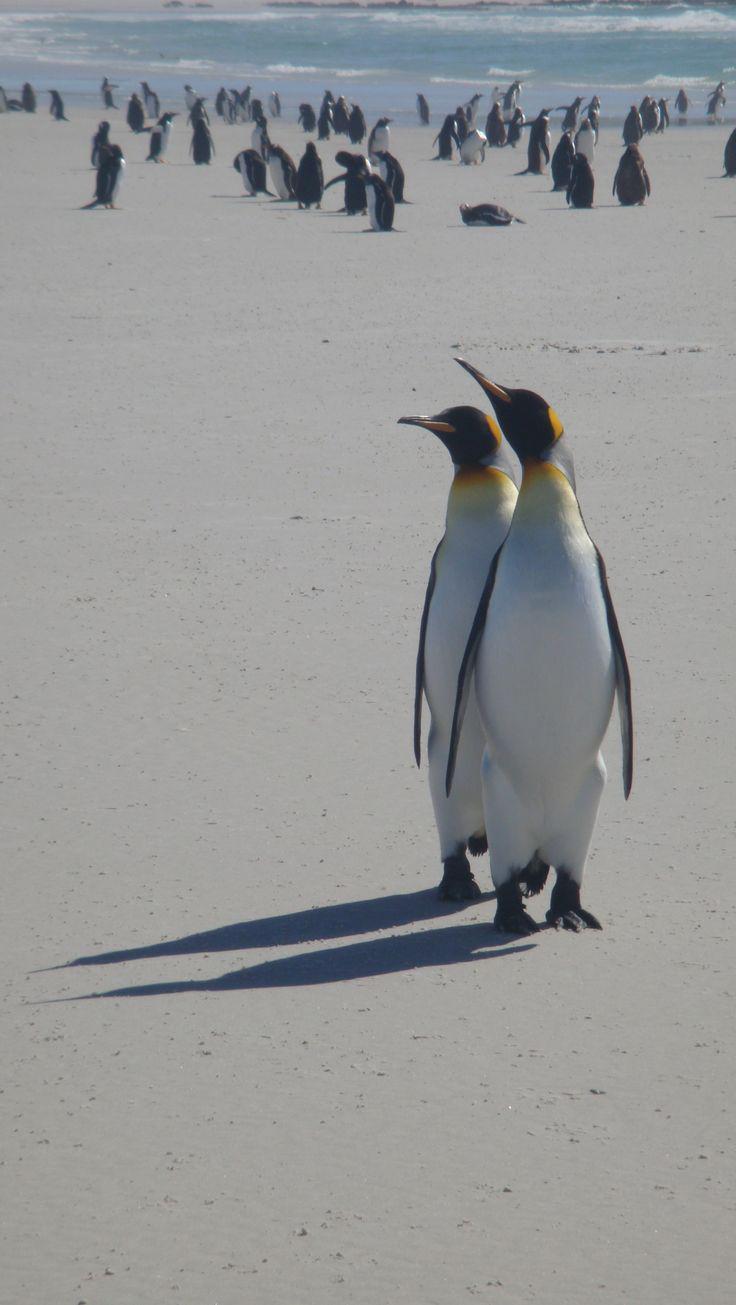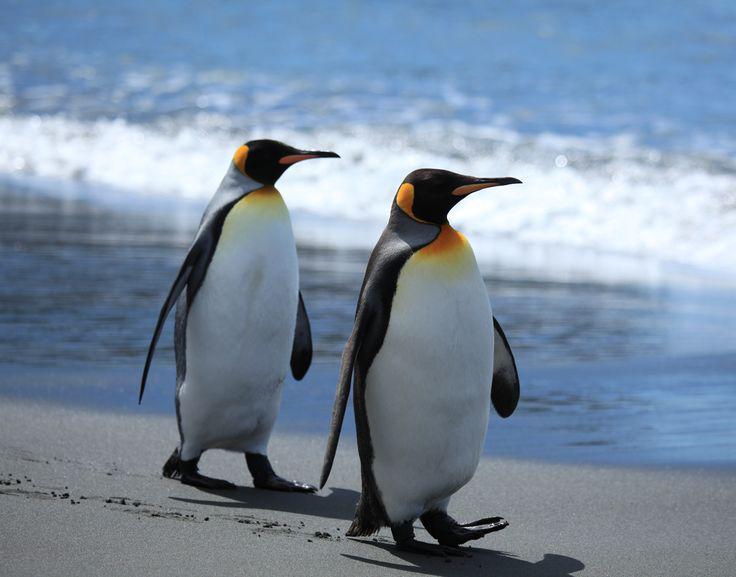The first image is the image on the left, the second image is the image on the right. Assess this claim about the two images: "An image shows multiple penguins swimming underwater where no ocean bottom is visible.". Correct or not? Answer yes or no. No. The first image is the image on the left, the second image is the image on the right. Given the left and right images, does the statement "There are no more than 2 penguins in one of the images." hold true? Answer yes or no. Yes. 